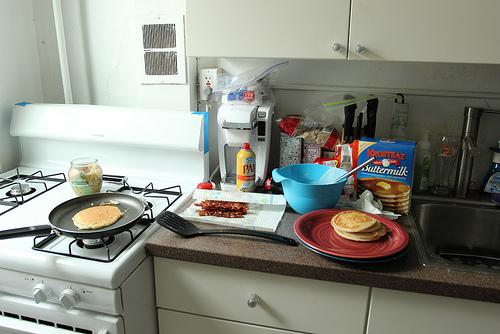Question: where is this scene?
Choices:
A. Living room.
B. A kitchen.
C. Bathroom.
D. Bedroom.
Answer with the letter. Answer: B Question: what is for breakfast?
Choices:
A. Eggs.
B. Casserole.
C. Waffles.
D. Pancakes & bacon.
Answer with the letter. Answer: D Question: where is the pancake being cooked?
Choices:
A. The stove.
B. Oven.
C. Griddle.
D. Pan.
Answer with the letter. Answer: A Question: what keeps the pancakes from sticking to the pan?
Choices:
A. Pam.
B. Butter.
C. Oil.
D. Nonstick pan.
Answer with the letter. Answer: A Question: what color is the plate?
Choices:
A. Red.
B. Blue.
C. Green.
D. Orange.
Answer with the letter. Answer: A 